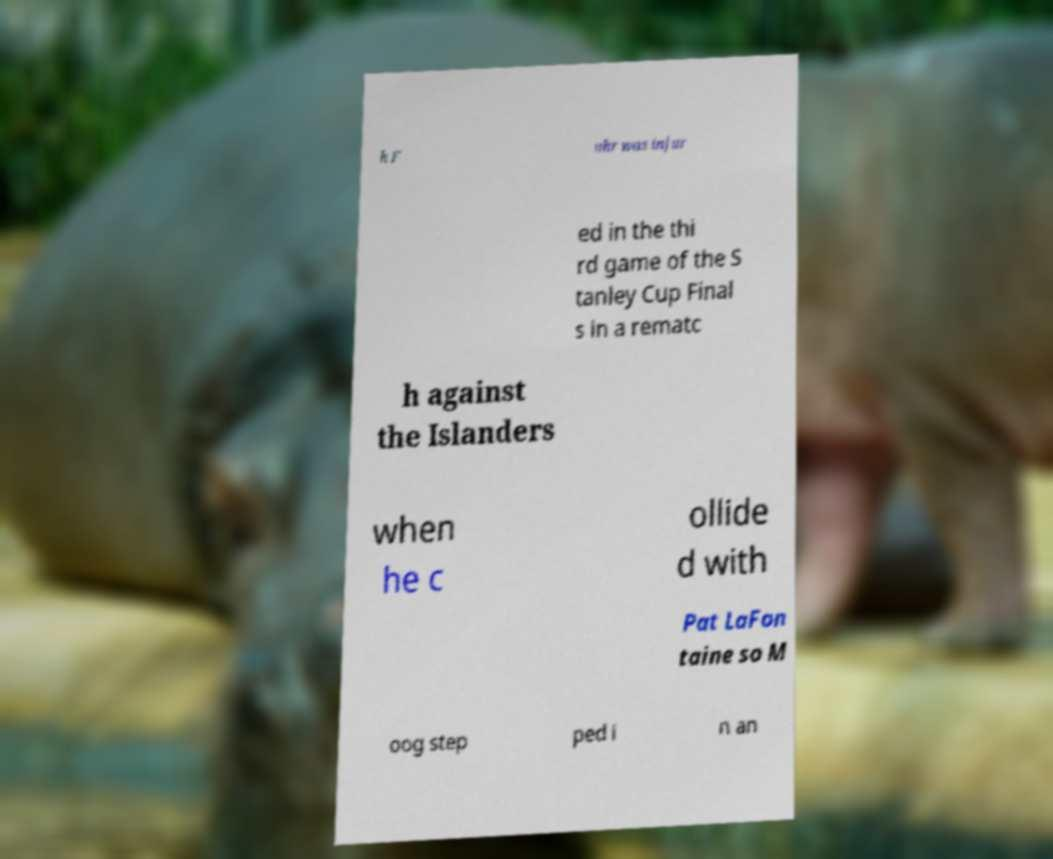Could you assist in decoding the text presented in this image and type it out clearly? h F uhr was injur ed in the thi rd game of the S tanley Cup Final s in a rematc h against the Islanders when he c ollide d with Pat LaFon taine so M oog step ped i n an 